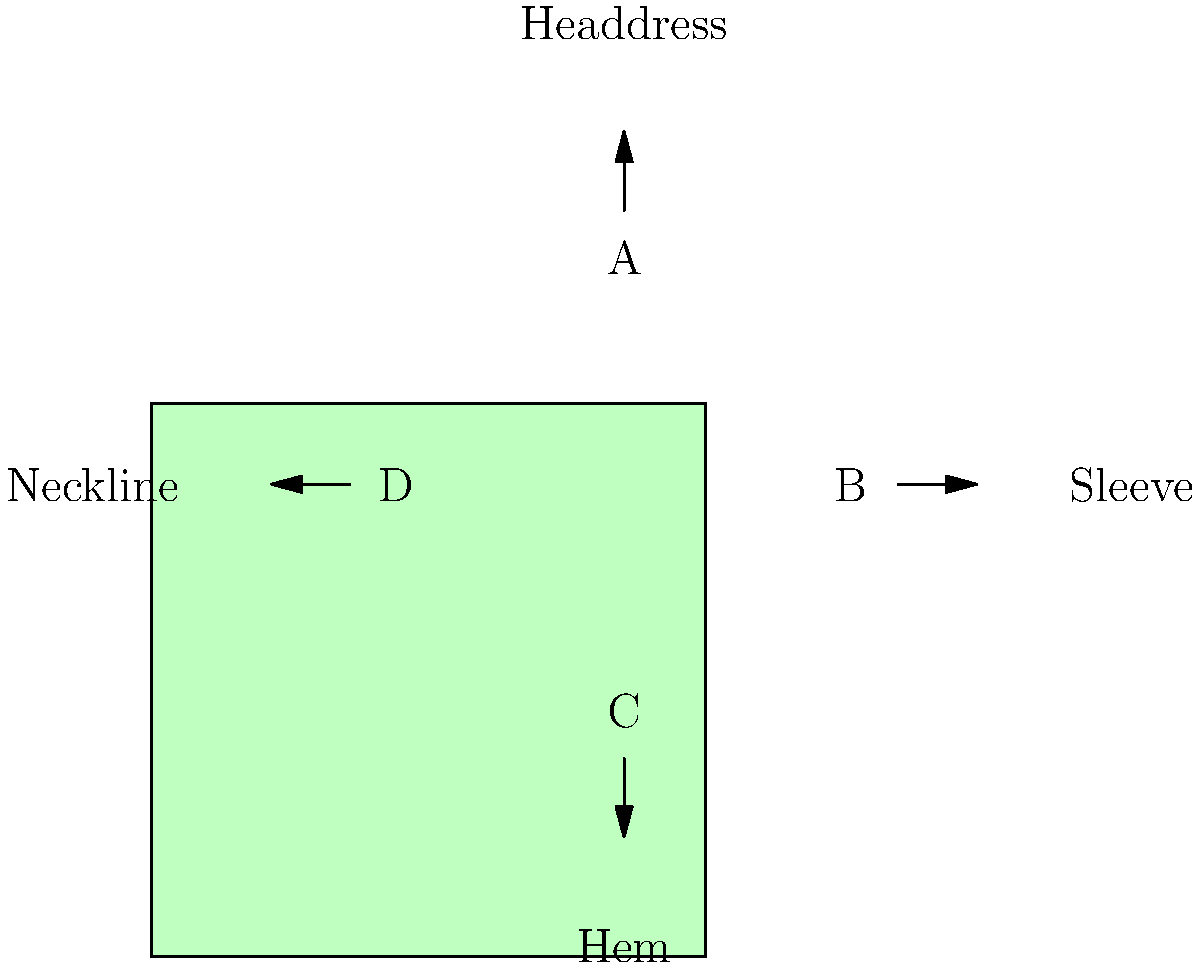In your research on traditional clothing for your manuscript, you come across this diagram representing key elements of a cultural garment. Which part of the garment, labeled in the diagram, is typically associated with intricate embroidery and often reflects the wearer's social status or regional identity? To answer this question, let's consider each labeled part of the garment and its typical significance in traditional clothing:

1. Headdress (A): While headdresses can be ornate, they are not typically the primary canvas for intricate embroidery reflecting social status or regional identity.

2. Sleeve (B): Sleeves in traditional garments often feature elaborate embroidery. The patterns and designs on sleeves can vary significantly between regions and can indicate the wearer's social status, marital status, or cultural affiliation.

3. Hem (C): The hem of a garment is sometimes decorated, but it's not the most common place for intricate embroidery that reflects status or identity.

4. Neckline (D): Necklines can be decorated, but they generally don't carry as much significance in terms of social status or regional identity as other parts of the garment.

Among these options, the sleeve (B) is most commonly associated with intricate embroidery that reflects the wearer's social status or regional identity. In many cultures, sleeves serve as a canvas for elaborate designs, patterns, and symbols that can indicate:

- The wearer's social class or rank
- Marital status
- Regional or tribal affiliation
- Family lineage
- Specific cultural or religious symbolism

For example, in some Eastern European cultures, the embroidery on a woman's sleeve might indicate her marital status or home village. In certain Asian cultures, the intricacy and materials used in sleeve embroidery can denote social class.

Therefore, the sleeve (B) is the most likely answer to this question about cultural garments and their significance.
Answer: Sleeve (B) 